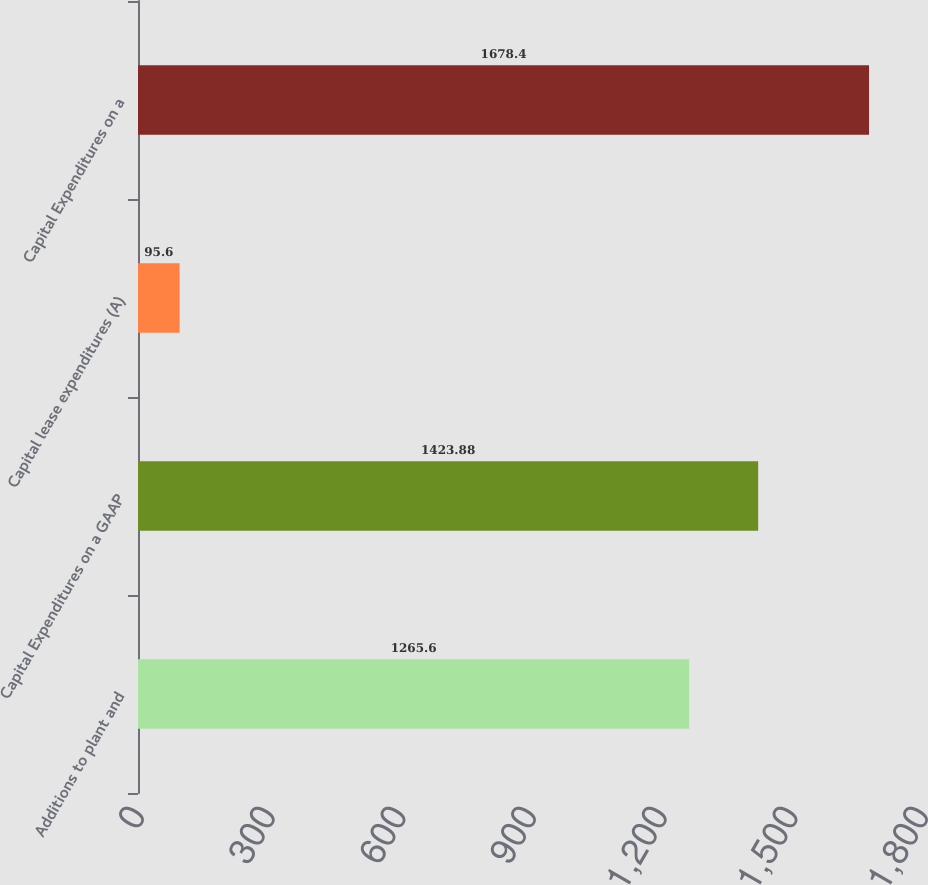Convert chart. <chart><loc_0><loc_0><loc_500><loc_500><bar_chart><fcel>Additions to plant and<fcel>Capital Expenditures on a GAAP<fcel>Capital lease expenditures (A)<fcel>Capital Expenditures on a<nl><fcel>1265.6<fcel>1423.88<fcel>95.6<fcel>1678.4<nl></chart> 